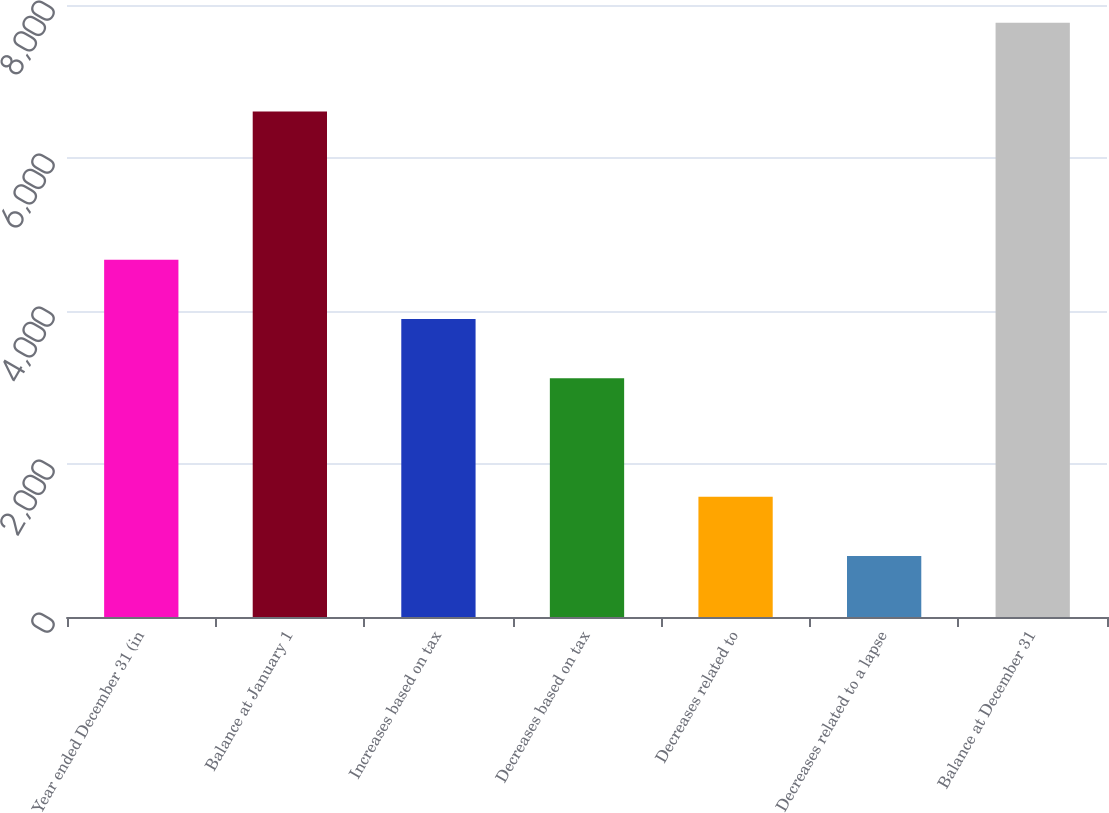Convert chart. <chart><loc_0><loc_0><loc_500><loc_500><bar_chart><fcel>Year ended December 31 (in<fcel>Balance at January 1<fcel>Increases based on tax<fcel>Decreases based on tax<fcel>Decreases related to<fcel>Decreases related to a lapse<fcel>Balance at December 31<nl><fcel>4669.8<fcel>6608<fcel>3895.5<fcel>3121.2<fcel>1572.6<fcel>798.3<fcel>7767<nl></chart> 